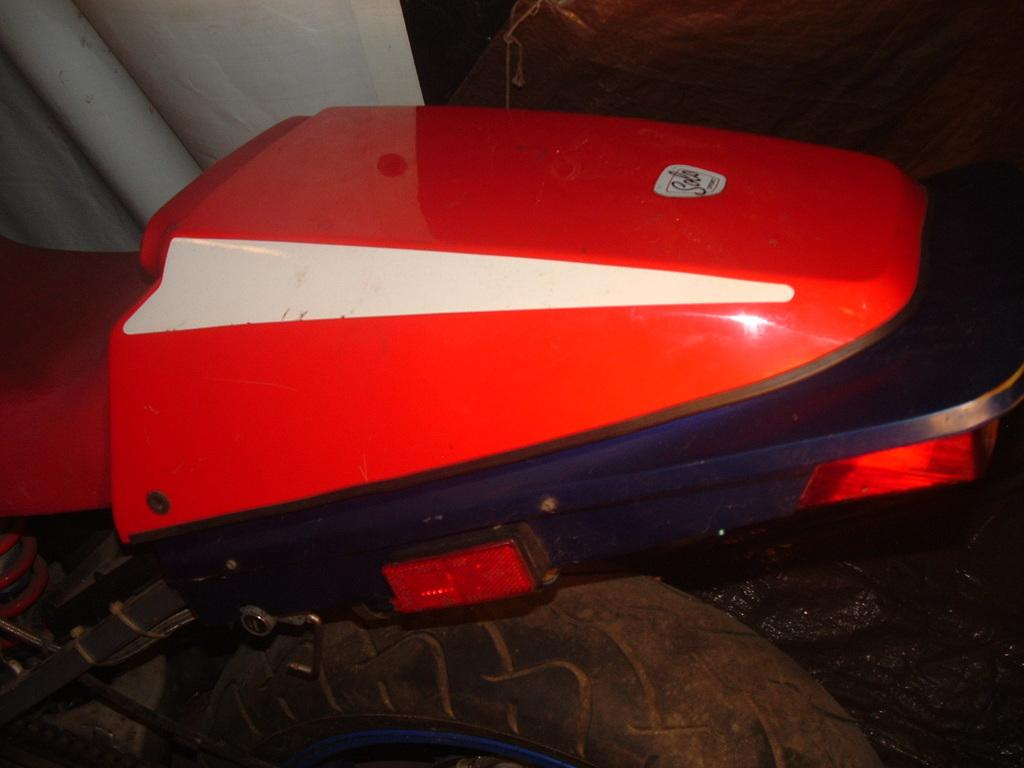What type of vehicle is partially visible in the image? The back part of a motorcycle is visible in the image. What other object can be seen in the image? There is a pipe in the image. How would you describe the lighting or color of the background in the image? The background of the image is dark. What type of jam is being spread on the bit in the image? There is no jam or bit present in the image; it only features the back part of a motorcycle and a pipe. 